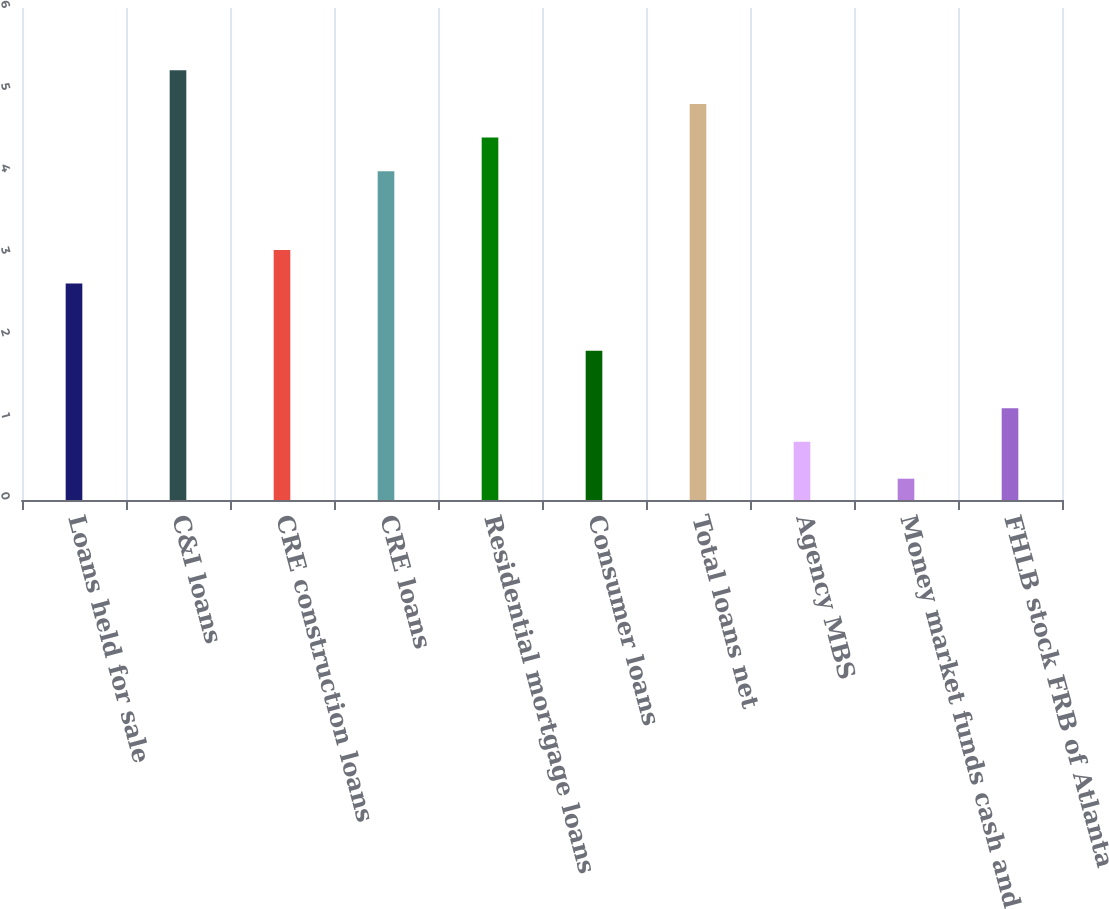Convert chart. <chart><loc_0><loc_0><loc_500><loc_500><bar_chart><fcel>Loans held for sale<fcel>C&I loans<fcel>CRE construction loans<fcel>CRE loans<fcel>Residential mortgage loans<fcel>Consumer loans<fcel>Total loans net<fcel>Agency MBS<fcel>Money market funds cash and<fcel>FHLB stock FRB of Atlanta<nl><fcel>2.64<fcel>5.24<fcel>3.05<fcel>4.01<fcel>4.42<fcel>1.82<fcel>4.83<fcel>0.71<fcel>0.26<fcel>1.12<nl></chart> 